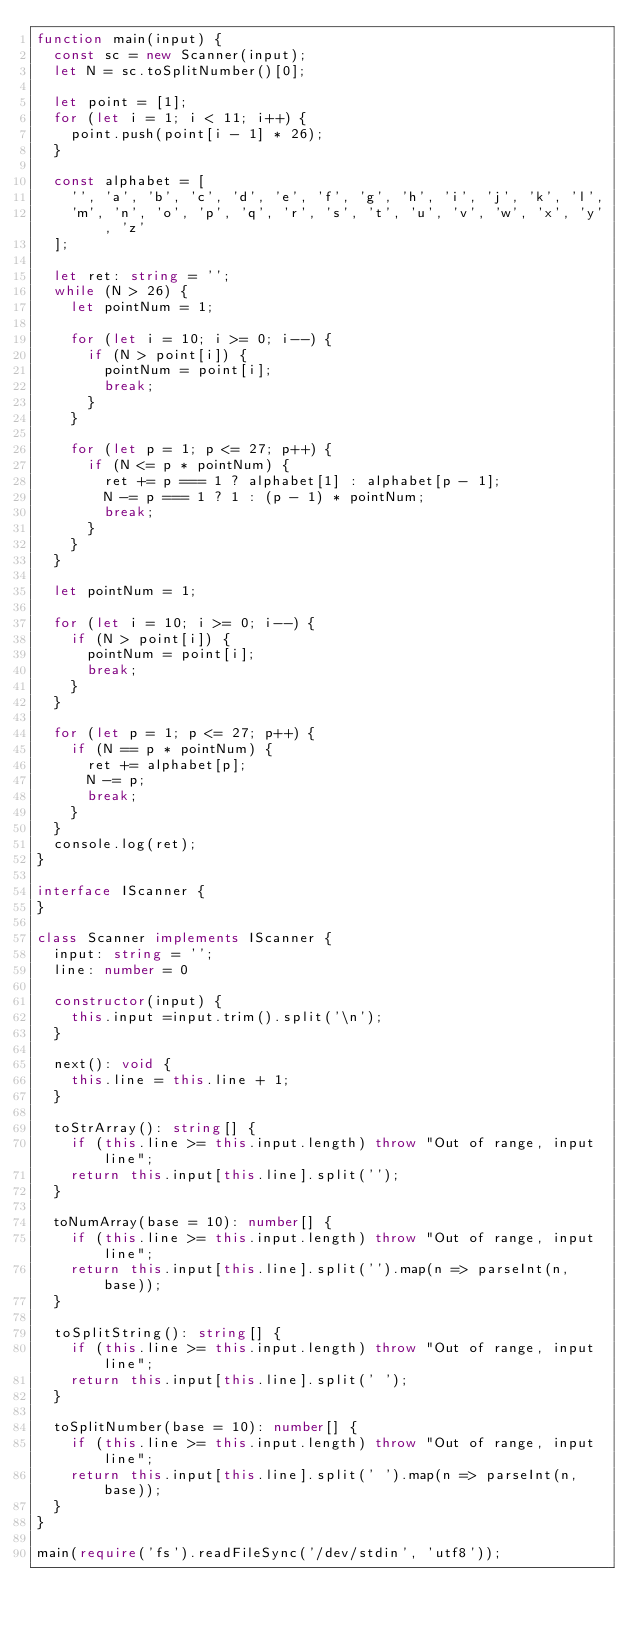Convert code to text. <code><loc_0><loc_0><loc_500><loc_500><_TypeScript_>function main(input) {
  const sc = new Scanner(input);
  let N = sc.toSplitNumber()[0];

  let point = [1];
  for (let i = 1; i < 11; i++) {
    point.push(point[i - 1] * 26);
  }

  const alphabet = [
    '', 'a', 'b', 'c', 'd', 'e', 'f', 'g', 'h', 'i', 'j', 'k', 'l',
    'm', 'n', 'o', 'p', 'q', 'r', 's', 't', 'u', 'v', 'w', 'x', 'y', 'z'
  ];

  let ret: string = '';
  while (N > 26) {
    let pointNum = 1;

    for (let i = 10; i >= 0; i--) {
      if (N > point[i]) {
        pointNum = point[i];
        break;
      }
    }

    for (let p = 1; p <= 27; p++) {
      if (N <= p * pointNum) {
        ret += p === 1 ? alphabet[1] : alphabet[p - 1];
        N -= p === 1 ? 1 : (p - 1) * pointNum;
        break;
      }
    }
  }

  let pointNum = 1;

  for (let i = 10; i >= 0; i--) {
    if (N > point[i]) {
      pointNum = point[i];
      break;
    }
  }

  for (let p = 1; p <= 27; p++) {
    if (N == p * pointNum) {
      ret += alphabet[p];
      N -= p;
      break;
    }
  }
  console.log(ret);
}

interface IScanner {
}

class Scanner implements IScanner {
  input: string = '';
  line: number = 0

  constructor(input) {
    this.input =input.trim().split('\n');
  }

  next(): void {
    this.line = this.line + 1;
  }

  toStrArray(): string[] {
    if (this.line >= this.input.length) throw "Out of range, input line";
    return this.input[this.line].split('');
  }

  toNumArray(base = 10): number[] {
    if (this.line >= this.input.length) throw "Out of range, input line";
    return this.input[this.line].split('').map(n => parseInt(n, base));
  }

  toSplitString(): string[] {
    if (this.line >= this.input.length) throw "Out of range, input line";
    return this.input[this.line].split(' ');
  }

  toSplitNumber(base = 10): number[] {
    if (this.line >= this.input.length) throw "Out of range, input line";
    return this.input[this.line].split(' ').map(n => parseInt(n, base));
  }
}

main(require('fs').readFileSync('/dev/stdin', 'utf8'));
</code> 